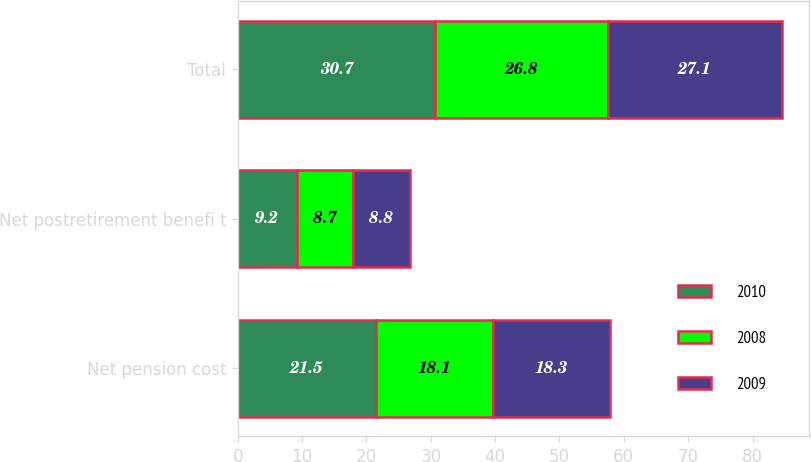Convert chart to OTSL. <chart><loc_0><loc_0><loc_500><loc_500><stacked_bar_chart><ecel><fcel>Net pension cost<fcel>Net postretirement benefi t<fcel>Total<nl><fcel>2010<fcel>21.5<fcel>9.2<fcel>30.7<nl><fcel>2008<fcel>18.1<fcel>8.7<fcel>26.8<nl><fcel>2009<fcel>18.3<fcel>8.8<fcel>27.1<nl></chart> 